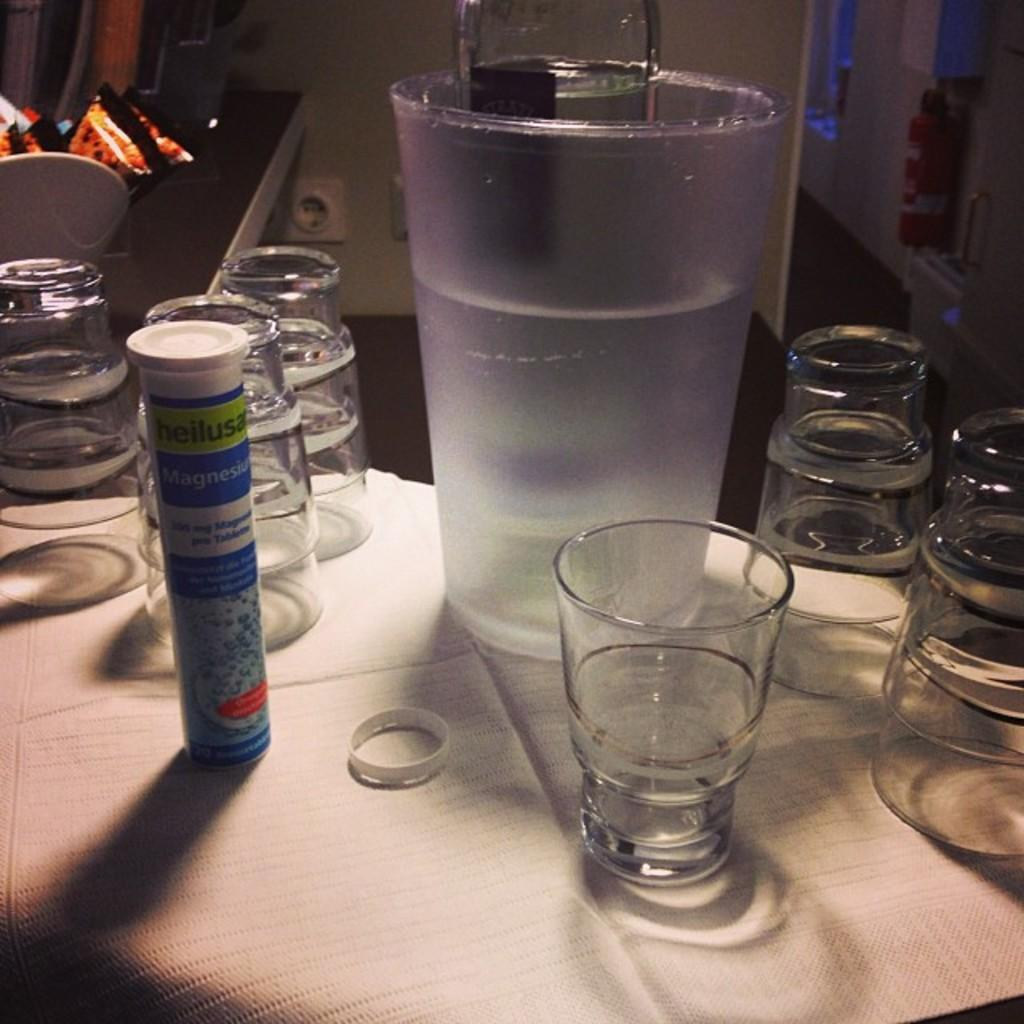What piece of furniture is present in the image? There is a table in the image. What is placed on the table? There is a glass and a bottle on the table. What is the status of the bottle's cap? The bottle has a cap on it. What can be seen in the background of the image? There is a white color wall in the background. What is located on the right side of the image? There is a cupboard on the right side of the image. Where is the crown placed on the table in the image? There is no crown present in the image. What type of jewel can be seen in the glass on the table? There are no jewels visible in the glass on the table; it contains a liquid, likely a beverage. 